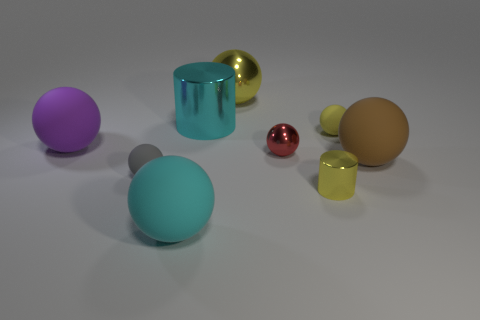Subtract 4 spheres. How many spheres are left? 3 Subtract all yellow balls. How many balls are left? 5 Subtract all gray spheres. How many spheres are left? 6 Subtract all red spheres. Subtract all purple cubes. How many spheres are left? 6 Add 1 tiny cyan metallic cylinders. How many objects exist? 10 Subtract all spheres. How many objects are left? 2 Subtract 1 yellow spheres. How many objects are left? 8 Subtract all large brown rubber balls. Subtract all large purple matte objects. How many objects are left? 7 Add 6 small yellow metal cylinders. How many small yellow metal cylinders are left? 7 Add 3 small brown matte spheres. How many small brown matte spheres exist? 3 